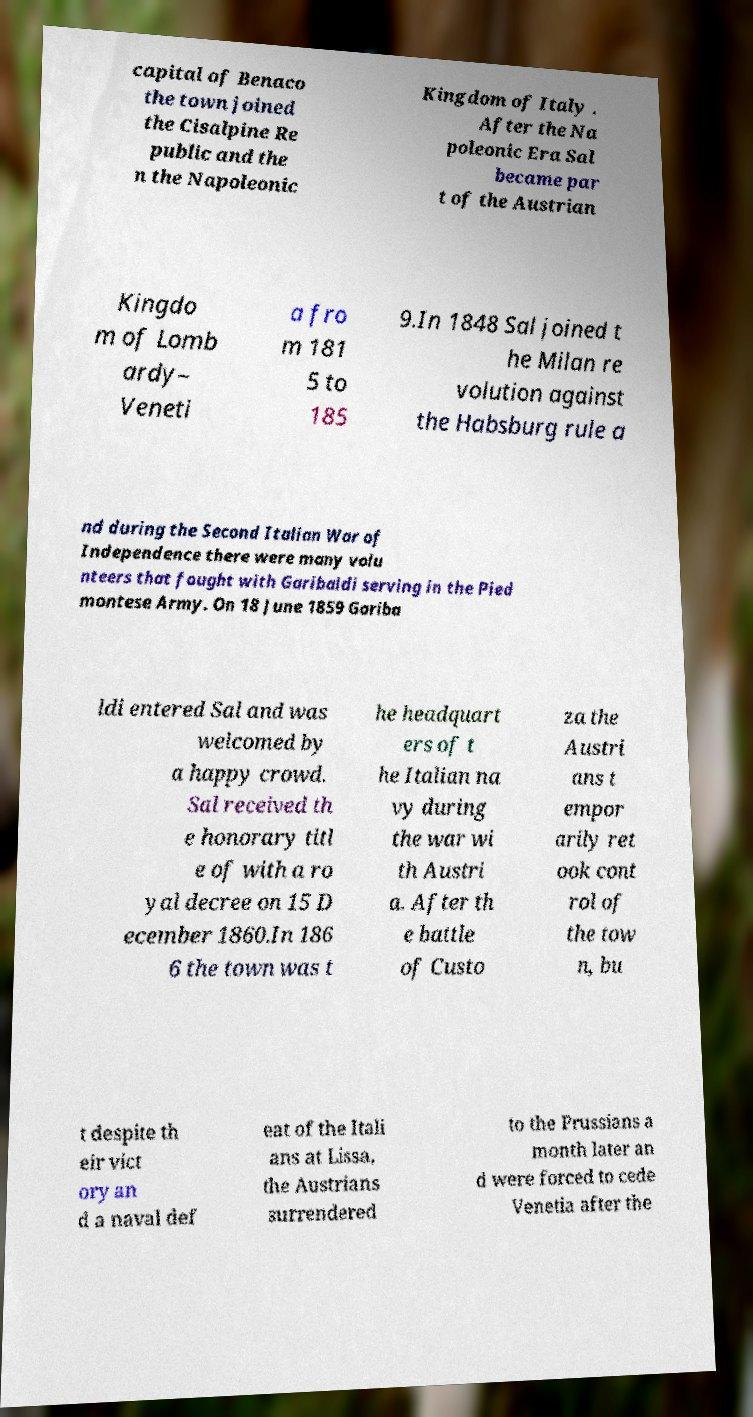Please read and relay the text visible in this image. What does it say? capital of Benaco the town joined the Cisalpine Re public and the n the Napoleonic Kingdom of Italy . After the Na poleonic Era Sal became par t of the Austrian Kingdo m of Lomb ardy– Veneti a fro m 181 5 to 185 9.In 1848 Sal joined t he Milan re volution against the Habsburg rule a nd during the Second Italian War of Independence there were many volu nteers that fought with Garibaldi serving in the Pied montese Army. On 18 June 1859 Gariba ldi entered Sal and was welcomed by a happy crowd. Sal received th e honorary titl e of with a ro yal decree on 15 D ecember 1860.In 186 6 the town was t he headquart ers of t he Italian na vy during the war wi th Austri a. After th e battle of Custo za the Austri ans t empor arily ret ook cont rol of the tow n, bu t despite th eir vict ory an d a naval def eat of the Itali ans at Lissa, the Austrians surrendered to the Prussians a month later an d were forced to cede Venetia after the 